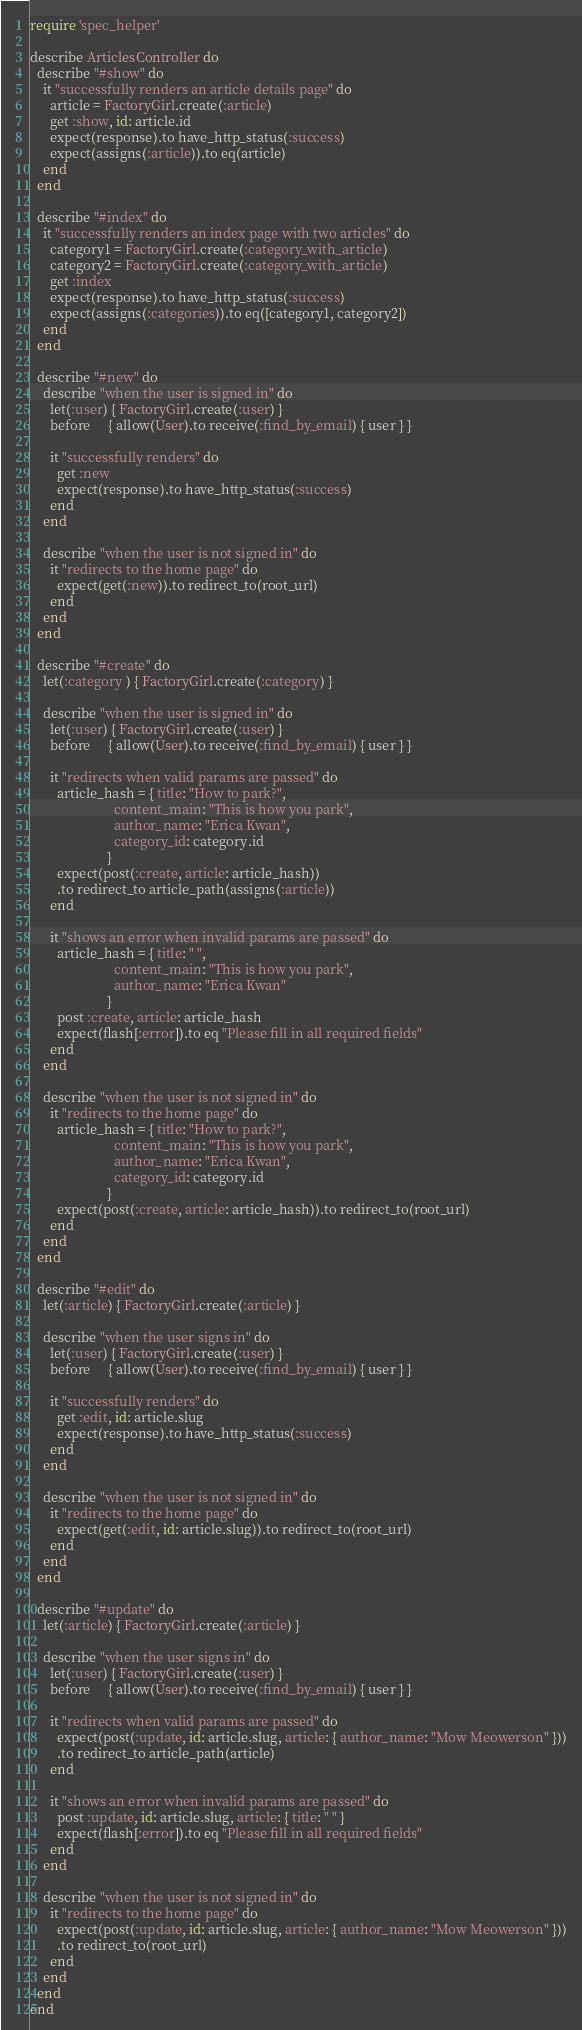<code> <loc_0><loc_0><loc_500><loc_500><_Ruby_>require 'spec_helper'

describe ArticlesController do
  describe "#show" do
    it "successfully renders an article details page" do
      article = FactoryGirl.create(:article)
      get :show, id: article.id
      expect(response).to have_http_status(:success)
      expect(assigns(:article)).to eq(article)
    end
  end

  describe "#index" do
    it "successfully renders an index page with two articles" do
      category1 = FactoryGirl.create(:category_with_article)
      category2 = FactoryGirl.create(:category_with_article)
      get :index
      expect(response).to have_http_status(:success)
      expect(assigns(:categories)).to eq([category1, category2])
    end
  end

  describe "#new" do
    describe "when the user is signed in" do
      let(:user) { FactoryGirl.create(:user) }
      before     { allow(User).to receive(:find_by_email) { user } }

      it "successfully renders" do
        get :new
        expect(response).to have_http_status(:success)
      end
    end

    describe "when the user is not signed in" do
      it "redirects to the home page" do
        expect(get(:new)).to redirect_to(root_url)
      end
    end
  end

  describe "#create" do
    let(:category ) { FactoryGirl.create(:category) }

    describe "when the user is signed in" do
      let(:user) { FactoryGirl.create(:user) }
      before     { allow(User).to receive(:find_by_email) { user } }

      it "redirects when valid params are passed" do
        article_hash = { title: "How to park?",
                         content_main: "This is how you park",
                         author_name: "Erica Kwan",
                         category_id: category.id
                       }
        expect(post(:create, article: article_hash))
        .to redirect_to article_path(assigns(:article))
      end

      it "shows an error when invalid params are passed" do
        article_hash = { title: " ",
                         content_main: "This is how you park",
                         author_name: "Erica Kwan"
                       }
        post :create, article: article_hash
        expect(flash[:error]).to eq "Please fill in all required fields"
      end
    end

    describe "when the user is not signed in" do
      it "redirects to the home page" do
        article_hash = { title: "How to park?",
                         content_main: "This is how you park",
                         author_name: "Erica Kwan",
                         category_id: category.id
                       }
        expect(post(:create, article: article_hash)).to redirect_to(root_url)
      end
    end
  end

  describe "#edit" do
    let(:article) { FactoryGirl.create(:article) }

    describe "when the user signs in" do
      let(:user) { FactoryGirl.create(:user) }
      before     { allow(User).to receive(:find_by_email) { user } }

      it "successfully renders" do
        get :edit, id: article.slug
        expect(response).to have_http_status(:success)
      end
    end

    describe "when the user is not signed in" do
      it "redirects to the home page" do
        expect(get(:edit, id: article.slug)).to redirect_to(root_url)
      end
    end
  end

  describe "#update" do
    let(:article) { FactoryGirl.create(:article) }

    describe "when the user signs in" do
      let(:user) { FactoryGirl.create(:user) }
      before     { allow(User).to receive(:find_by_email) { user } }

      it "redirects when valid params are passed" do
        expect(post(:update, id: article.slug, article: { author_name: "Mow Meowerson" }))
        .to redirect_to article_path(article)
      end

      it "shows an error when invalid params are passed" do
        post :update, id: article.slug, article: { title: " " }
        expect(flash[:error]).to eq "Please fill in all required fields"
      end
    end

    describe "when the user is not signed in" do
      it "redirects to the home page" do
        expect(post(:update, id: article.slug, article: { author_name: "Mow Meowerson" }))
        .to redirect_to(root_url)
      end
    end
  end
end
</code> 